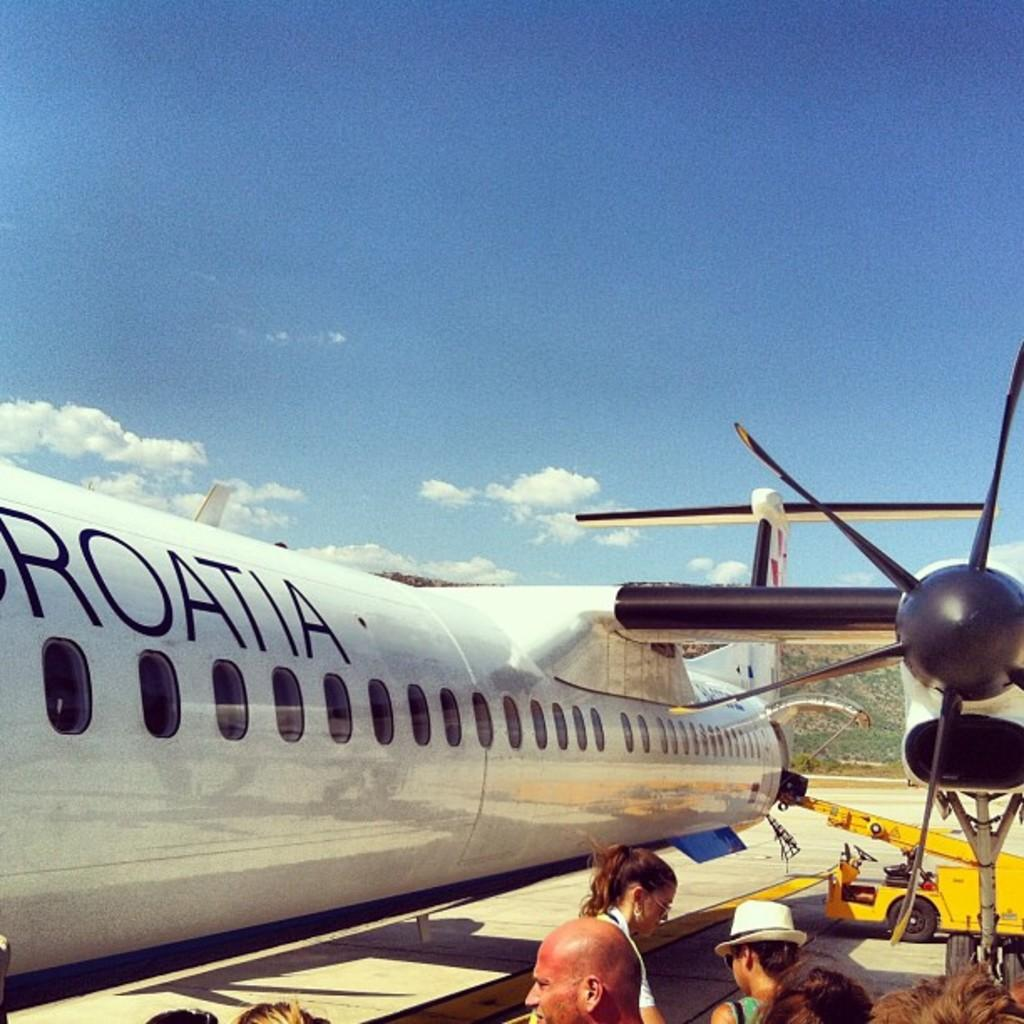What can be seen in the image involving transportation? There is an airplane and a vehicle in the image. What are the people in the image doing? The facts do not specify what the people are doing, but they are standing in the image. What is visible in the background of the image? The sky is visible in the image. Are there any volcanoes visible in the image? No, there are no volcanoes present in the image. What type of cakes are being served to the people in the image? There is no mention of cakes in the image, so it cannot be determined if they are being served or present. 